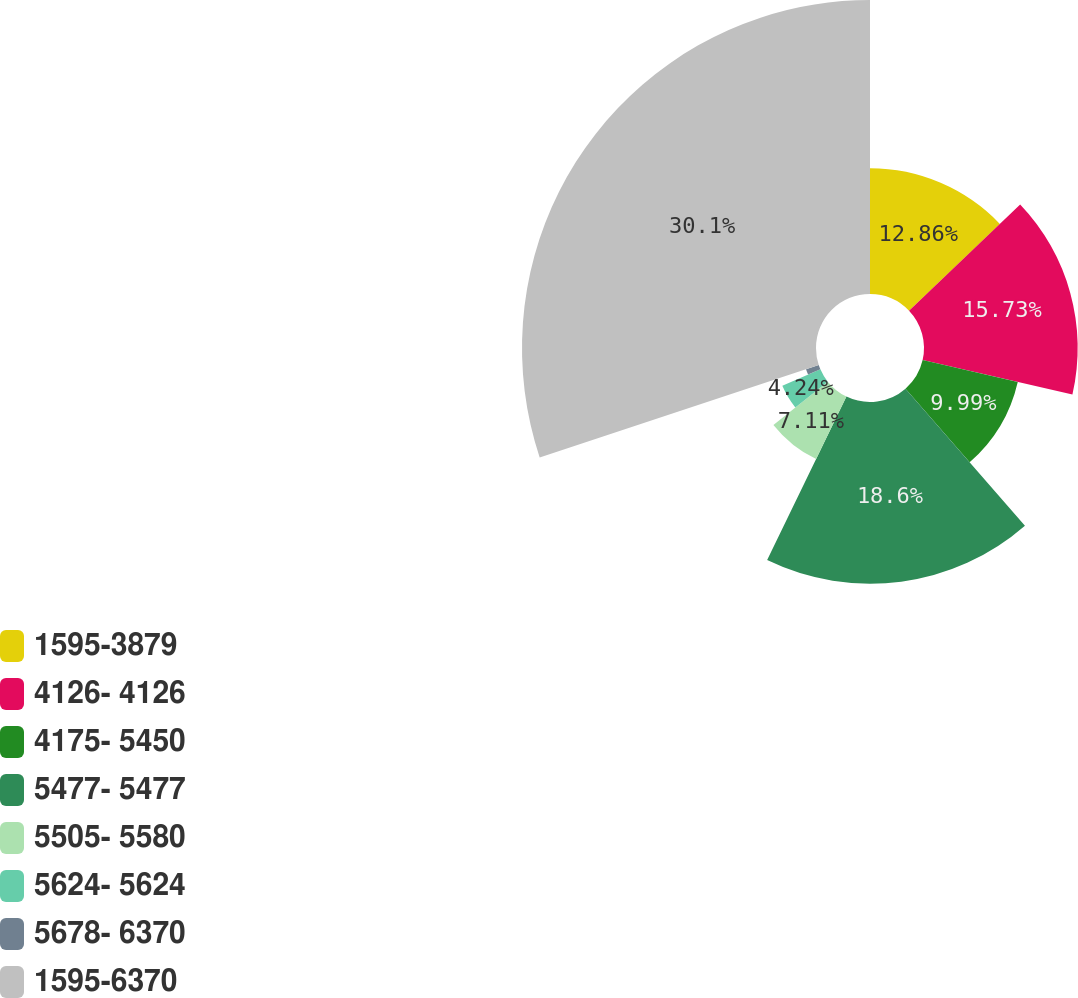Convert chart. <chart><loc_0><loc_0><loc_500><loc_500><pie_chart><fcel>1595-3879<fcel>4126- 4126<fcel>4175- 5450<fcel>5477- 5477<fcel>5505- 5580<fcel>5624- 5624<fcel>5678- 6370<fcel>1595-6370<nl><fcel>12.86%<fcel>15.73%<fcel>9.99%<fcel>18.6%<fcel>7.11%<fcel>4.24%<fcel>1.37%<fcel>30.09%<nl></chart> 